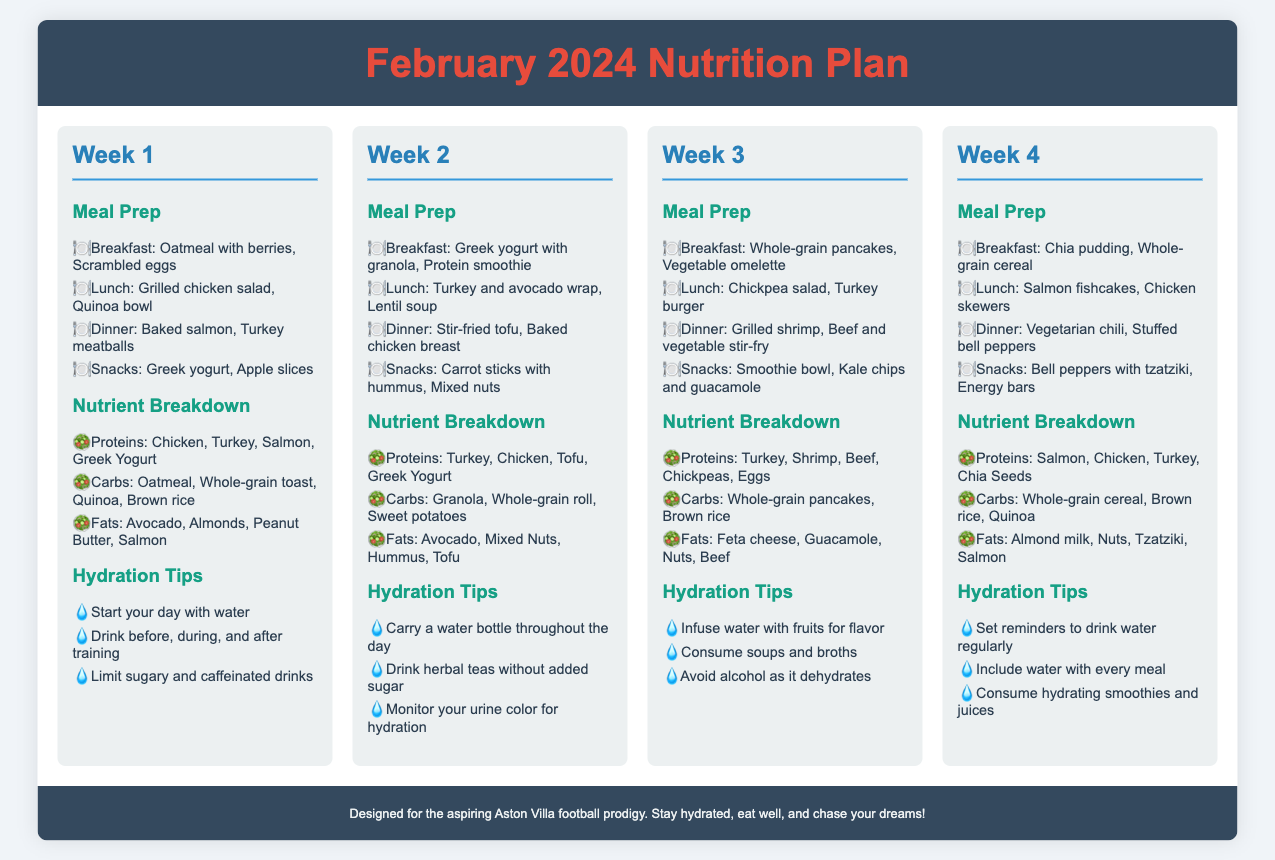what is the title of the document? The title of the document is presented at the top, which is "February 2024 Nutrition Plan."
Answer: February 2024 Nutrition Plan how many weeks are included in the nutrition plan? The document outlines a nutrition plan for four weeks, as evidenced by the four sections labeled "Week 1" to "Week 4."
Answer: 4 what protein sources are listed for Week 1? The protein sources listed for Week 1 include Chicken, Turkey, Salmon, and Greek Yogurt, as mentioned in the nutrient breakdown section.
Answer: Chicken, Turkey, Salmon, Greek Yogurt what is one hydration tip from Week 3? Week 3 provides hydration tips, where one specific suggestion is to "Infuse water with fruits for flavor."
Answer: Infuse water with fruits for flavor which meal includes oatmeal in Week 1? The meal preparation for Week 1 indicates that "Oatmeal with berries" is included in the breakfast section.
Answer: Breakfast what is the main carbohydrate source in Week 2? The nutrient breakdown for Week 2 includes Granola, Whole-grain roll, and Sweet potatoes as carbohydrate sources.
Answer: Granola, Whole-grain roll, Sweet potatoes which week features a stir-fried tofu dinner? The document indicates that a stir-fried tofu dinner is featured in Week 2.
Answer: Week 2 what type of snack is mentioned in Week 4? Week 4 lists "Bell peppers with tzatziki" and "Energy bars," which are categorized as snacks.
Answer: Bell peppers with tzatziki, Energy bars 